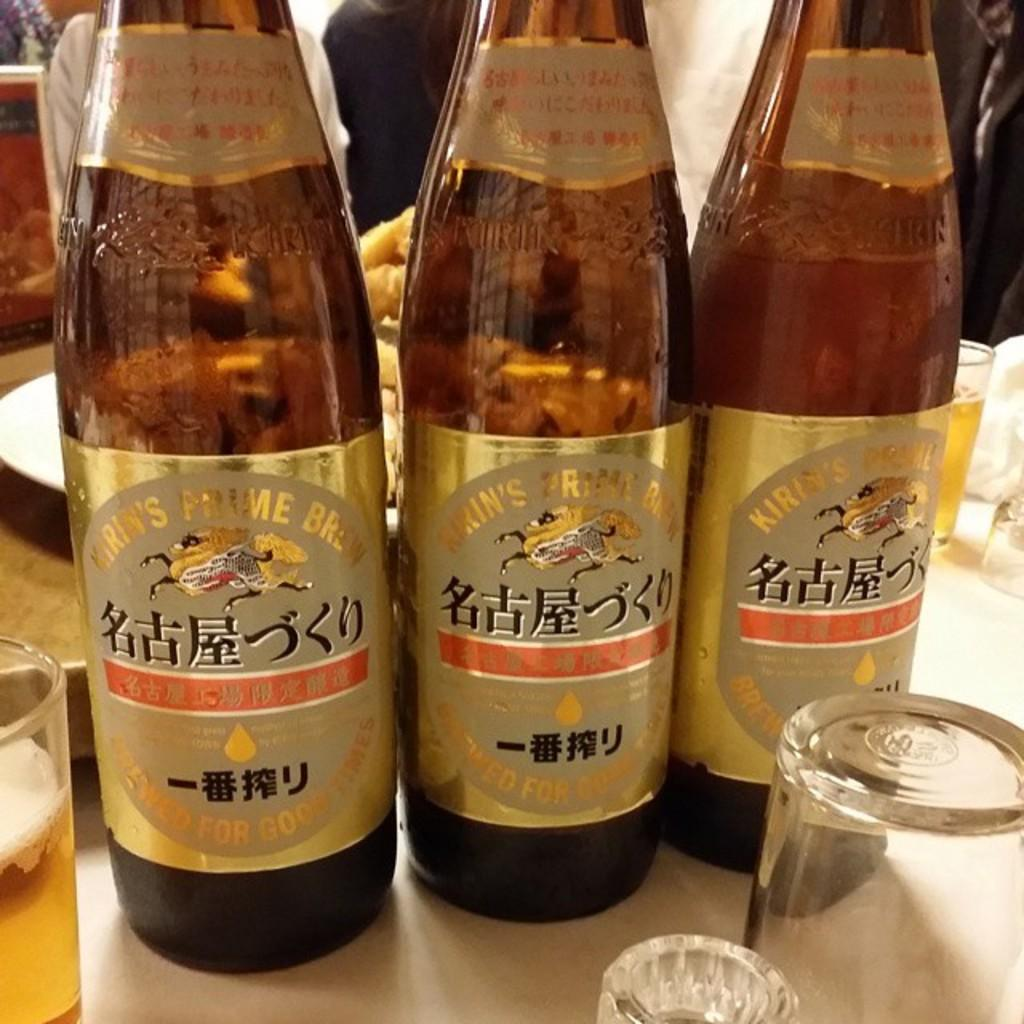<image>
Offer a succinct explanation of the picture presented. Three bottles of beer say "brewed for good times" at the bottom of the labels. 